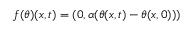<formula> <loc_0><loc_0><loc_500><loc_500>f ( \theta ) ( x , t ) = ( 0 , \alpha ( \theta ( x , t ) - \theta ( x , 0 ) ) )</formula> 